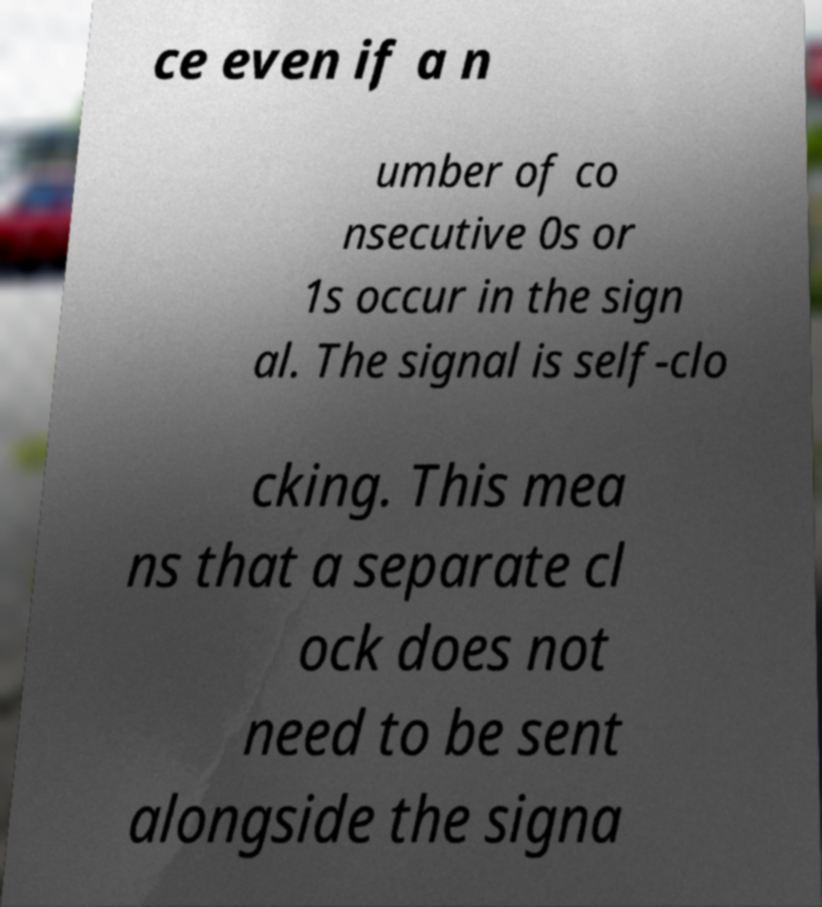I need the written content from this picture converted into text. Can you do that? ce even if a n umber of co nsecutive 0s or 1s occur in the sign al. The signal is self-clo cking. This mea ns that a separate cl ock does not need to be sent alongside the signa 